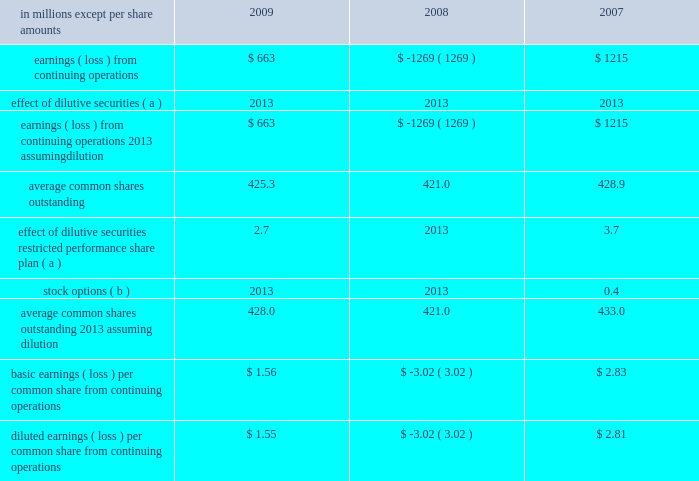In april 2009 , the fasb issued additional guidance under asc 820 which provides guidance on estimat- ing the fair value of an asset or liability ( financial or nonfinancial ) when the volume and level of activity for the asset or liability have significantly decreased , and on identifying transactions that are not orderly .
The application of the requirements of this guidance did not have a material effect on the accompanying consolidated financial statements .
In august 2009 , the fasb issued asu 2009-05 , 201cmeasuring liabilities at fair value , 201d which further amends asc 820 by providing clarification for cir- cumstances in which a quoted price in an active market for the identical liability is not available .
The company included the disclosures required by this guidance in the accompanying consolidated financial statements .
Accounting for uncertainty in income taxes in june 2006 , the fasb issued guidance under asc 740 , 201cincome taxes 201d ( formerly fin 48 ) .
This guid- ance prescribes a recognition threshold and measurement attribute for the financial statement recognition and measurement of a tax position taken or expected to be taken in tax returns .
Specifically , the financial statement effects of a tax position may be recognized only when it is determined that it is 201cmore likely than not 201d that , based on its technical merits , the tax position will be sustained upon examination by the relevant tax authority .
The amount recognized shall be measured as the largest amount of tax benefits that exceed a 50% ( 50 % ) probability of being recognized .
This guidance also expands income tax disclosure requirements .
International paper applied the provisions of this guidance begin- ning in the first quarter of 2007 .
The adoption of this guidance resulted in a charge to the beginning bal- ance of retained earnings of $ 94 million at the date of adoption .
Note 3 industry segment information financial information by industry segment and geo- graphic area for 2009 , 2008 and 2007 is presented on pages 47 and 48 .
Effective january 1 , 2008 , the company changed its method of allocating corpo- rate overhead expenses to its business segments to increase the expense amounts allocated to these businesses in reports reviewed by its chief executive officer to facilitate performance comparisons with other companies .
Accordingly , the company has revised its presentation of industry segment operat- ing profit to reflect this change in allocation method , and has adjusted all comparative prior period information on this basis .
Note 4 earnings per share attributable to international paper company common shareholders basic earnings per common share from continuing operations are computed by dividing earnings from continuing operations by the weighted average number of common shares outstanding .
Diluted earnings per common share from continuing oper- ations are computed assuming that all potentially dilutive securities , including 201cin-the-money 201d stock options , were converted into common shares at the beginning of each year .
In addition , the computation of diluted earnings per share reflects the inclusion of contingently convertible securities in periods when dilutive .
A reconciliation of the amounts included in the computation of basic earnings per common share from continuing operations , and diluted earnings per common share from continuing operations is as fol- in millions except per share amounts 2009 2008 2007 .
Average common shares outstanding 2013 assuming dilution 428.0 421.0 433.0 basic earnings ( loss ) per common share from continuing operations $ 1.56 $ ( 3.02 ) $ 2.83 diluted earnings ( loss ) per common share from continuing operations $ 1.55 $ ( 3.02 ) $ 2.81 ( a ) securities are not included in the table in periods when anti- dilutive .
( b ) options to purchase 22.2 million , 25.1 million and 17.5 million shares for the years ended december 31 , 2009 , 2008 and 2007 , respectively , were not included in the computation of diluted common shares outstanding because their exercise price exceeded the average market price of the company 2019s common stock for each respective reporting date .
Note 5 restructuring and other charges this footnote discusses restructuring and other charges recorded for each of the three years included in the period ended december 31 , 2009 .
It .
What was the net change in diluted earnings ( loss ) per common share from continuing operations between 2008 and 2009? 
Computations: (1.55 - -3.02)
Answer: 4.57. 